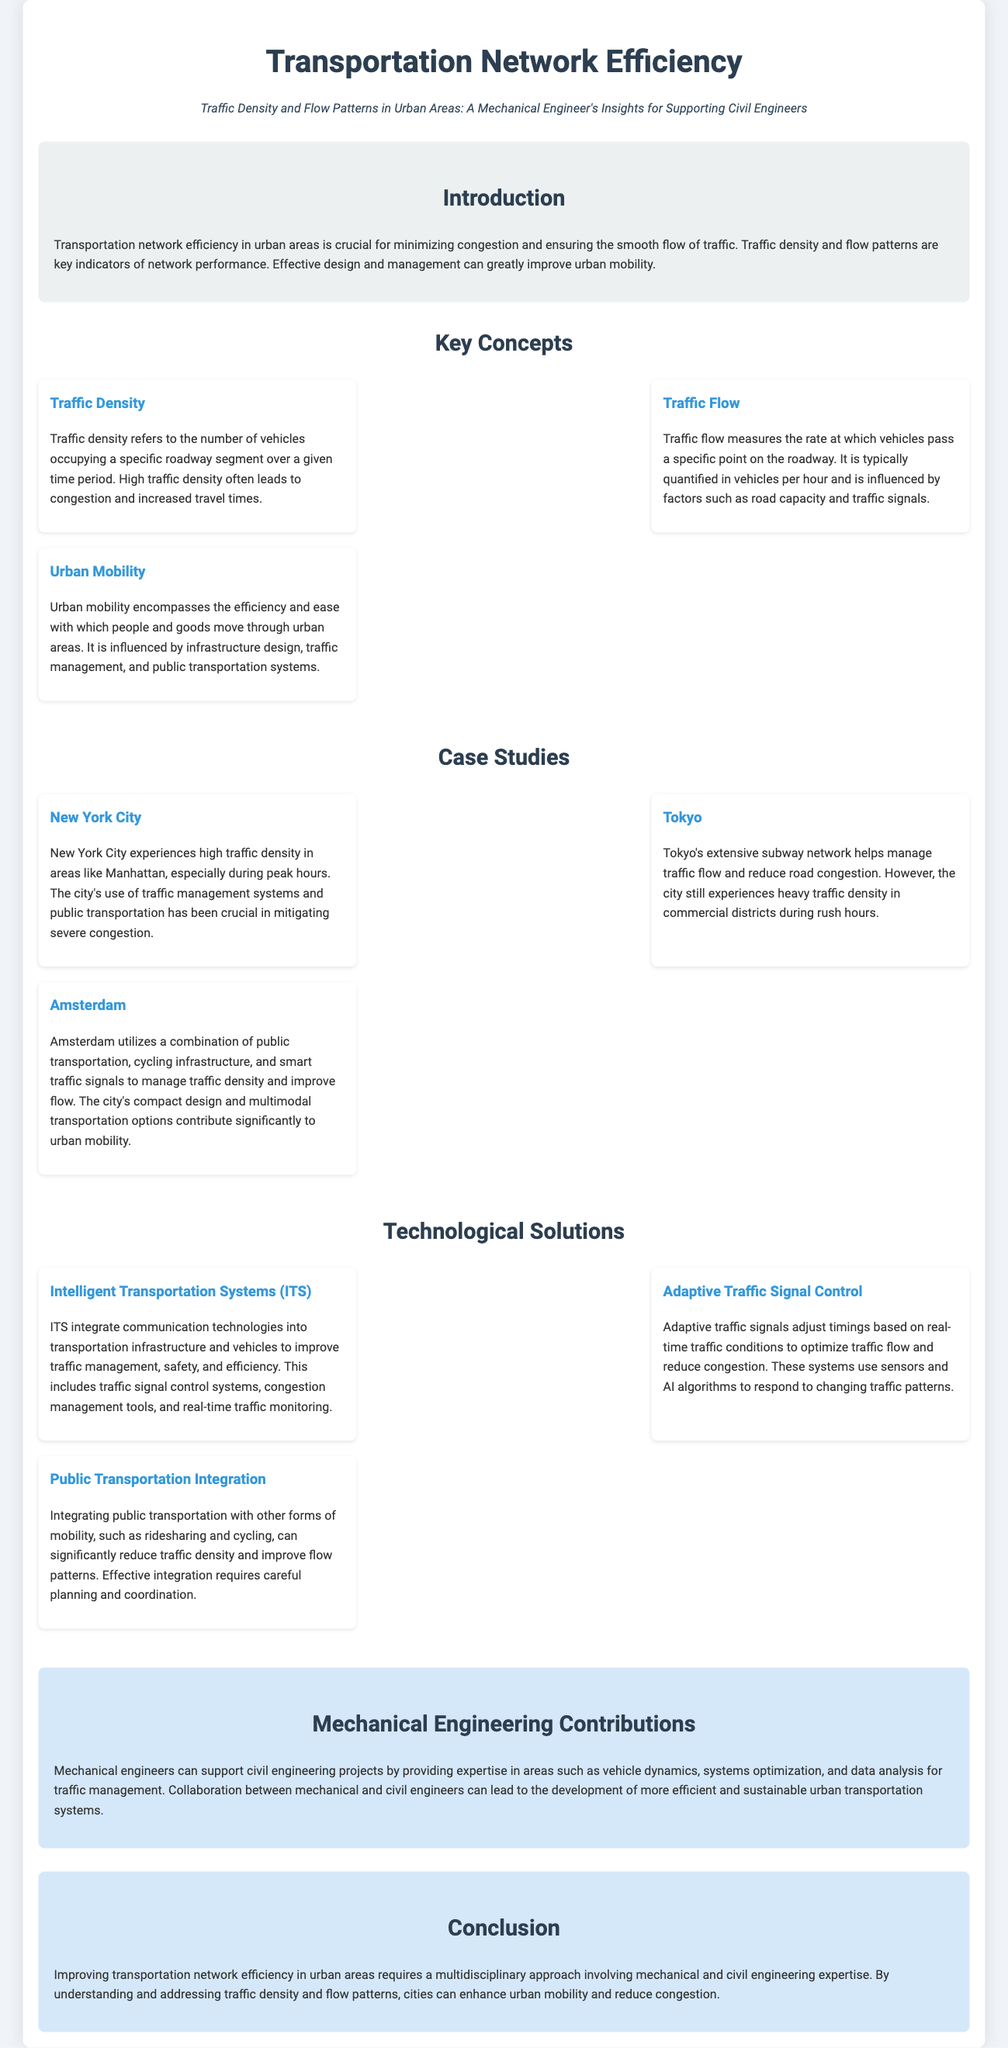What is the title of the document? The title of the document is presented at the top of the infographic.
Answer: Transportation Network Efficiency What are the three key concepts mentioned in the document? The key concepts are explicitly listed in the section about key concepts.
Answer: Traffic Density, Traffic Flow, Urban Mobility Which city uses a combination of public transportation and cycling infrastructure? The document provides specific case studies and identifies cities with certain strategies.
Answer: Amsterdam What technological solution improves traffic management and safety? The document discusses various technological solutions and highlights their roles in transportation efficiency.
Answer: Intelligent Transportation Systems (ITS) How does adaptive traffic signal control optimize traffic flow? The document explains the function of adaptive traffic signals in relation to traffic conditions.
Answer: Adjusts timings based on real-time traffic conditions What role do mechanical engineers play in transportation projects? The section on mechanical engineering contributions outlines the specific expertise these engineers bring to civil projects.
Answer: Vehicle dynamics, systems optimization, data analysis Which city experiences heavy traffic density in commercial districts? The document provides insights into traffic patterns in different cities.
Answer: Tokyo What happens to urban mobility with integration of public transportation? The document discusses the expected outcome of better public transportation integration on urban mobility.
Answer: It can significantly reduce traffic density and improve flow patterns 